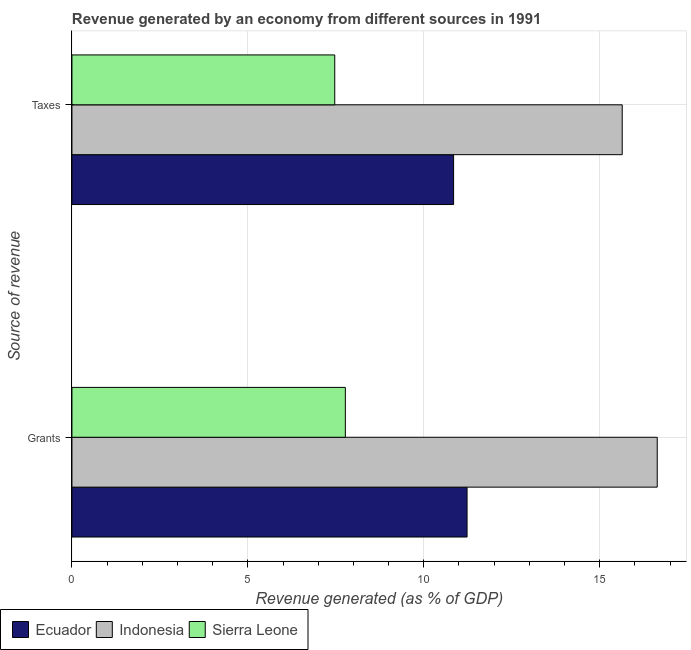Are the number of bars per tick equal to the number of legend labels?
Keep it short and to the point. Yes. How many bars are there on the 2nd tick from the top?
Your answer should be compact. 3. What is the label of the 1st group of bars from the top?
Your response must be concise. Taxes. What is the revenue generated by grants in Indonesia?
Ensure brevity in your answer.  16.64. Across all countries, what is the maximum revenue generated by taxes?
Your response must be concise. 15.64. Across all countries, what is the minimum revenue generated by grants?
Your answer should be very brief. 7.77. In which country was the revenue generated by taxes minimum?
Ensure brevity in your answer.  Sierra Leone. What is the total revenue generated by grants in the graph?
Your response must be concise. 35.64. What is the difference between the revenue generated by taxes in Sierra Leone and that in Ecuador?
Provide a succinct answer. -3.38. What is the difference between the revenue generated by taxes in Sierra Leone and the revenue generated by grants in Indonesia?
Ensure brevity in your answer.  -9.17. What is the average revenue generated by grants per country?
Your answer should be compact. 11.88. What is the difference between the revenue generated by grants and revenue generated by taxes in Ecuador?
Keep it short and to the point. 0.38. In how many countries, is the revenue generated by grants greater than 4 %?
Your answer should be very brief. 3. What is the ratio of the revenue generated by taxes in Indonesia to that in Ecuador?
Offer a terse response. 1.44. What does the 2nd bar from the top in Grants represents?
Keep it short and to the point. Indonesia. What does the 1st bar from the bottom in Taxes represents?
Ensure brevity in your answer.  Ecuador. What is the difference between two consecutive major ticks on the X-axis?
Keep it short and to the point. 5. Does the graph contain any zero values?
Keep it short and to the point. No. Does the graph contain grids?
Provide a succinct answer. Yes. Where does the legend appear in the graph?
Offer a terse response. Bottom left. How many legend labels are there?
Make the answer very short. 3. What is the title of the graph?
Make the answer very short. Revenue generated by an economy from different sources in 1991. What is the label or title of the X-axis?
Your response must be concise. Revenue generated (as % of GDP). What is the label or title of the Y-axis?
Give a very brief answer. Source of revenue. What is the Revenue generated (as % of GDP) in Ecuador in Grants?
Offer a very short reply. 11.23. What is the Revenue generated (as % of GDP) in Indonesia in Grants?
Keep it short and to the point. 16.64. What is the Revenue generated (as % of GDP) of Sierra Leone in Grants?
Keep it short and to the point. 7.77. What is the Revenue generated (as % of GDP) in Ecuador in Taxes?
Ensure brevity in your answer.  10.85. What is the Revenue generated (as % of GDP) in Indonesia in Taxes?
Your answer should be very brief. 15.64. What is the Revenue generated (as % of GDP) in Sierra Leone in Taxes?
Your answer should be very brief. 7.47. Across all Source of revenue, what is the maximum Revenue generated (as % of GDP) of Ecuador?
Provide a short and direct response. 11.23. Across all Source of revenue, what is the maximum Revenue generated (as % of GDP) in Indonesia?
Your response must be concise. 16.64. Across all Source of revenue, what is the maximum Revenue generated (as % of GDP) in Sierra Leone?
Make the answer very short. 7.77. Across all Source of revenue, what is the minimum Revenue generated (as % of GDP) of Ecuador?
Your answer should be very brief. 10.85. Across all Source of revenue, what is the minimum Revenue generated (as % of GDP) in Indonesia?
Keep it short and to the point. 15.64. Across all Source of revenue, what is the minimum Revenue generated (as % of GDP) in Sierra Leone?
Provide a short and direct response. 7.47. What is the total Revenue generated (as % of GDP) in Ecuador in the graph?
Offer a terse response. 22.08. What is the total Revenue generated (as % of GDP) of Indonesia in the graph?
Your response must be concise. 32.28. What is the total Revenue generated (as % of GDP) of Sierra Leone in the graph?
Offer a terse response. 15.24. What is the difference between the Revenue generated (as % of GDP) of Ecuador in Grants and that in Taxes?
Offer a terse response. 0.38. What is the difference between the Revenue generated (as % of GDP) of Sierra Leone in Grants and that in Taxes?
Ensure brevity in your answer.  0.3. What is the difference between the Revenue generated (as % of GDP) in Ecuador in Grants and the Revenue generated (as % of GDP) in Indonesia in Taxes?
Make the answer very short. -4.41. What is the difference between the Revenue generated (as % of GDP) in Ecuador in Grants and the Revenue generated (as % of GDP) in Sierra Leone in Taxes?
Give a very brief answer. 3.76. What is the difference between the Revenue generated (as % of GDP) of Indonesia in Grants and the Revenue generated (as % of GDP) of Sierra Leone in Taxes?
Your response must be concise. 9.17. What is the average Revenue generated (as % of GDP) in Ecuador per Source of revenue?
Provide a short and direct response. 11.04. What is the average Revenue generated (as % of GDP) in Indonesia per Source of revenue?
Your answer should be very brief. 16.14. What is the average Revenue generated (as % of GDP) in Sierra Leone per Source of revenue?
Ensure brevity in your answer.  7.62. What is the difference between the Revenue generated (as % of GDP) of Ecuador and Revenue generated (as % of GDP) of Indonesia in Grants?
Your response must be concise. -5.41. What is the difference between the Revenue generated (as % of GDP) of Ecuador and Revenue generated (as % of GDP) of Sierra Leone in Grants?
Provide a succinct answer. 3.46. What is the difference between the Revenue generated (as % of GDP) of Indonesia and Revenue generated (as % of GDP) of Sierra Leone in Grants?
Give a very brief answer. 8.86. What is the difference between the Revenue generated (as % of GDP) in Ecuador and Revenue generated (as % of GDP) in Indonesia in Taxes?
Provide a short and direct response. -4.79. What is the difference between the Revenue generated (as % of GDP) in Ecuador and Revenue generated (as % of GDP) in Sierra Leone in Taxes?
Provide a short and direct response. 3.38. What is the difference between the Revenue generated (as % of GDP) in Indonesia and Revenue generated (as % of GDP) in Sierra Leone in Taxes?
Provide a short and direct response. 8.17. What is the ratio of the Revenue generated (as % of GDP) in Ecuador in Grants to that in Taxes?
Your answer should be compact. 1.04. What is the ratio of the Revenue generated (as % of GDP) in Indonesia in Grants to that in Taxes?
Keep it short and to the point. 1.06. What is the ratio of the Revenue generated (as % of GDP) of Sierra Leone in Grants to that in Taxes?
Your response must be concise. 1.04. What is the difference between the highest and the second highest Revenue generated (as % of GDP) of Ecuador?
Offer a terse response. 0.38. What is the difference between the highest and the second highest Revenue generated (as % of GDP) in Sierra Leone?
Your response must be concise. 0.3. What is the difference between the highest and the lowest Revenue generated (as % of GDP) in Ecuador?
Ensure brevity in your answer.  0.38. What is the difference between the highest and the lowest Revenue generated (as % of GDP) in Indonesia?
Offer a very short reply. 0.99. What is the difference between the highest and the lowest Revenue generated (as % of GDP) of Sierra Leone?
Give a very brief answer. 0.3. 